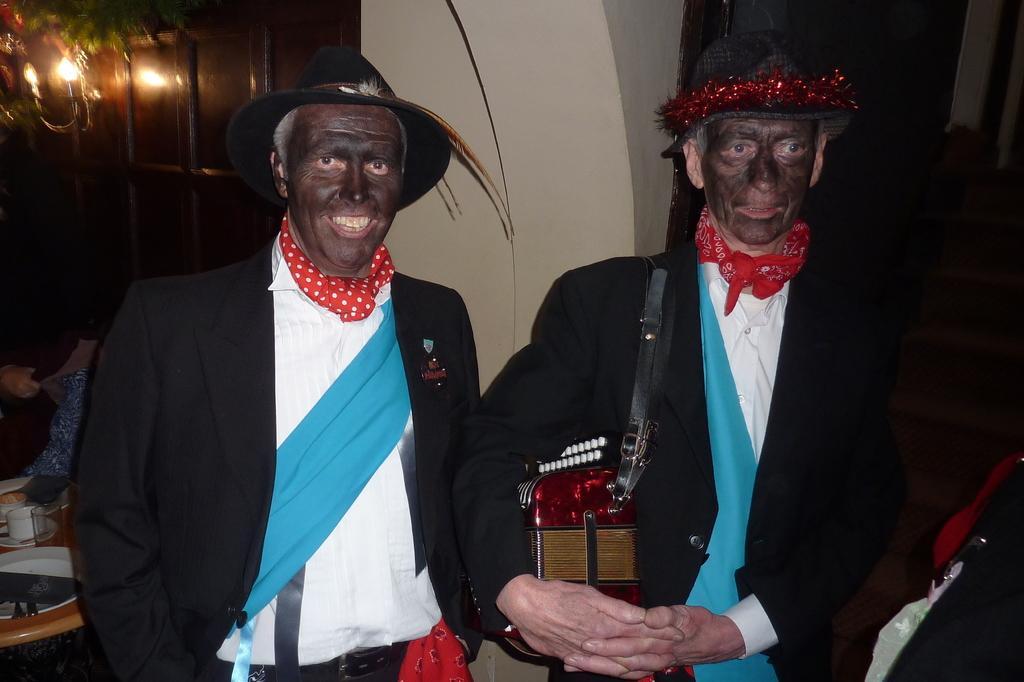Describe this image in one or two sentences. On the right side of the image we can see a person is standing and wearing a bag. On the left side of the image a person is standing. In the background of the image we can see doors, wall and lights are there. On the left side of the image there is a table. On the table we can see some plates, spoons, cups, glasses are present. 